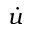<formula> <loc_0><loc_0><loc_500><loc_500>\dot { u }</formula> 